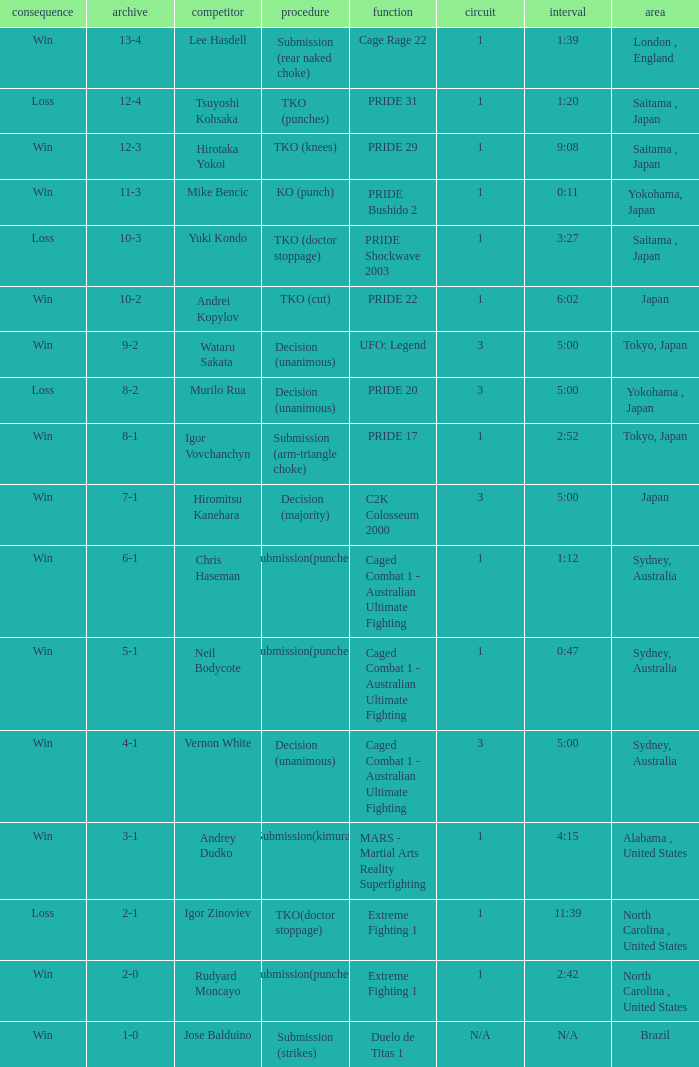Which Record has the Res of win with the Event of extreme fighting 1? 2-0. 